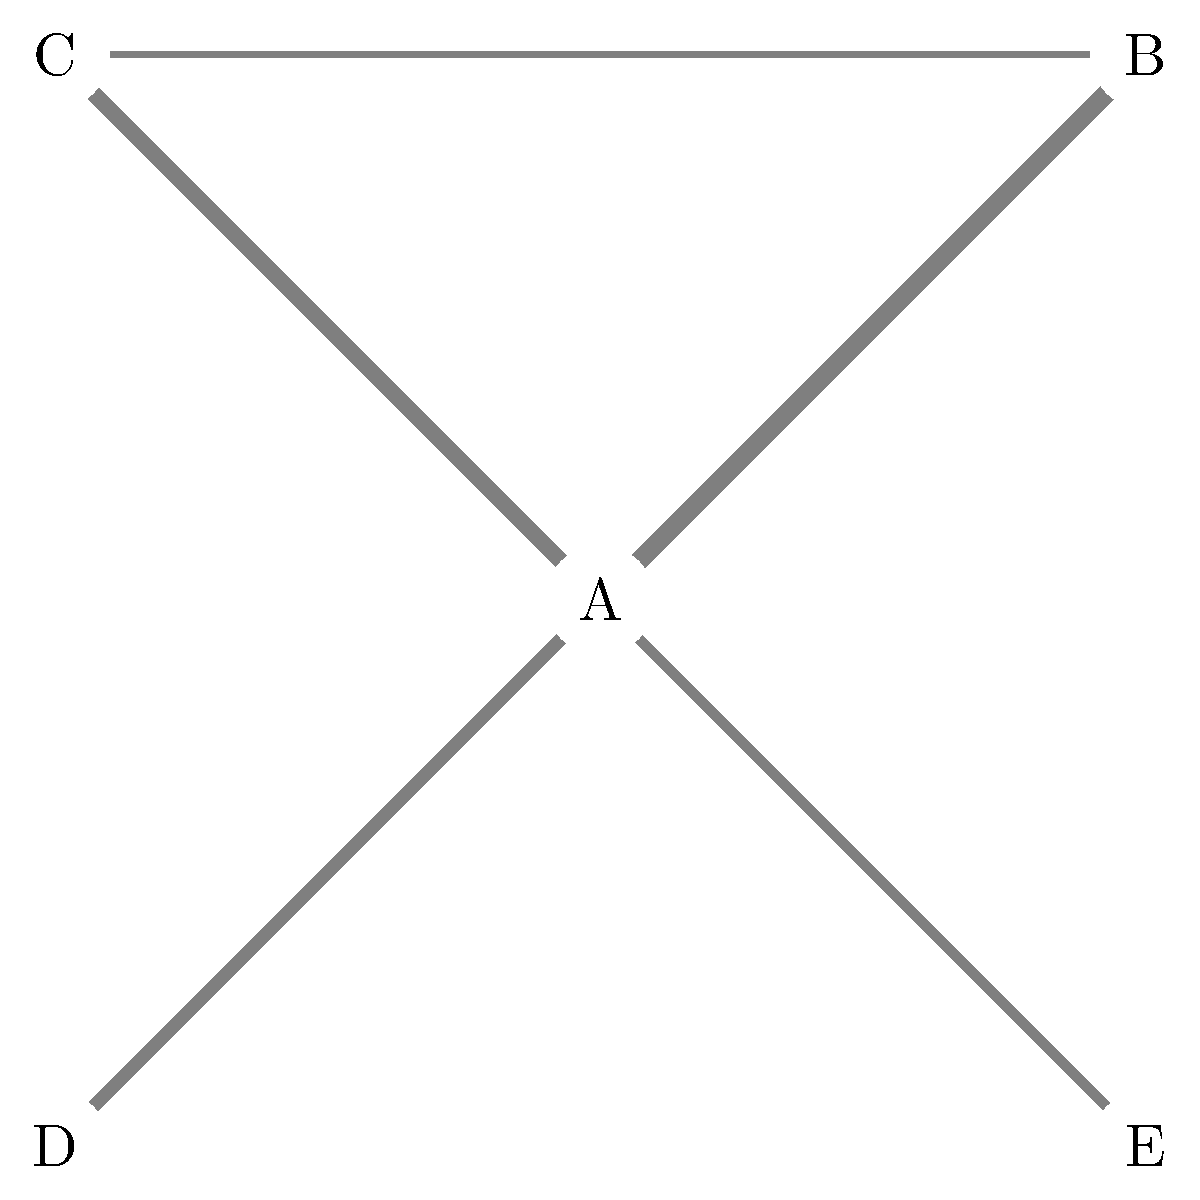In the network diagram representing the market share distribution of biotech products, node A represents your company's flagship product. The thickness of the edges connecting nodes represents the similarity or market overlap between products. Based on this information, which product (B, C, D, or E) would you consider the strongest competitor to your flagship product, and what strategic decision might you make to maintain your market position? To answer this question, we need to analyze the network diagram step-by-step:

1. Identify the flagship product: Node A represents our company's flagship product.

2. Analyze edge thickness: The thickness of the edges represents the similarity or market overlap between products. Thicker edges indicate greater similarity or overlap.

3. Compare edge thicknesses from node A:
   - A to B: Thickest edge
   - A to C: Second thickest edge
   - A to D: Third thickest edge
   - A to E: Thinnest edge

4. Identify the strongest competitor: Based on the edge thickness, product B has the thickest connection to A, indicating the greatest market overlap or similarity. Therefore, product B is the strongest competitor.

5. Strategic decision: To maintain market position, we should consider the following options:
   a. Differentiation: Enhance unique features of our flagship product to distinguish it from product B.
   b. Innovation: Invest in R&D to improve our product or develop new complementary products.
   c. Marketing: Strengthen marketing efforts to highlight our product's advantages over B.
   d. Pricing strategy: Adjust pricing to remain competitive against B while maintaining profitability.
   e. Partnership or acquisition: Consider partnering with or acquiring the company producing product B to consolidate market share.

The most appropriate strategic decision would be to focus on differentiation and innovation, as these align well with the strengths of a biotech company and can provide long-term competitive advantages.
Answer: Product B; Focus on differentiation and innovation 